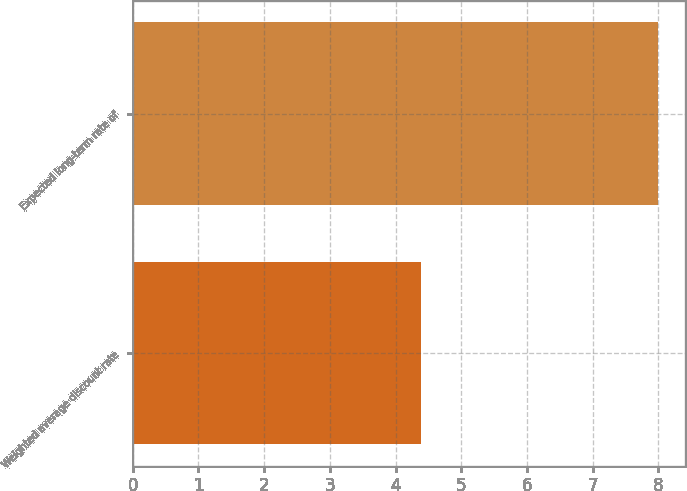Convert chart to OTSL. <chart><loc_0><loc_0><loc_500><loc_500><bar_chart><fcel>Weighted average discount rate<fcel>Expected long-term rate of<nl><fcel>4.38<fcel>8<nl></chart> 